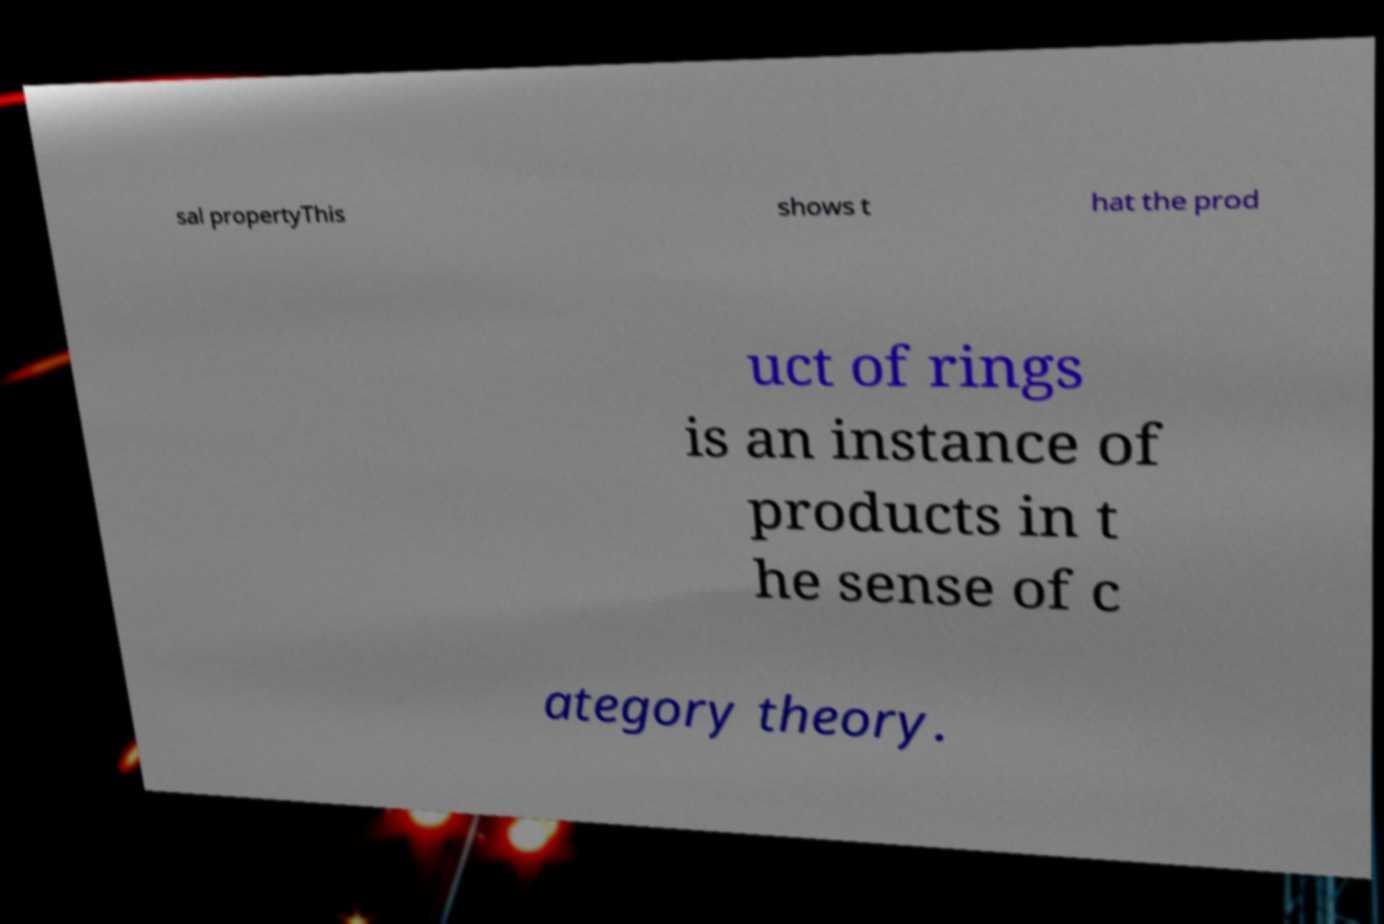Can you accurately transcribe the text from the provided image for me? sal propertyThis shows t hat the prod uct of rings is an instance of products in t he sense of c ategory theory. 